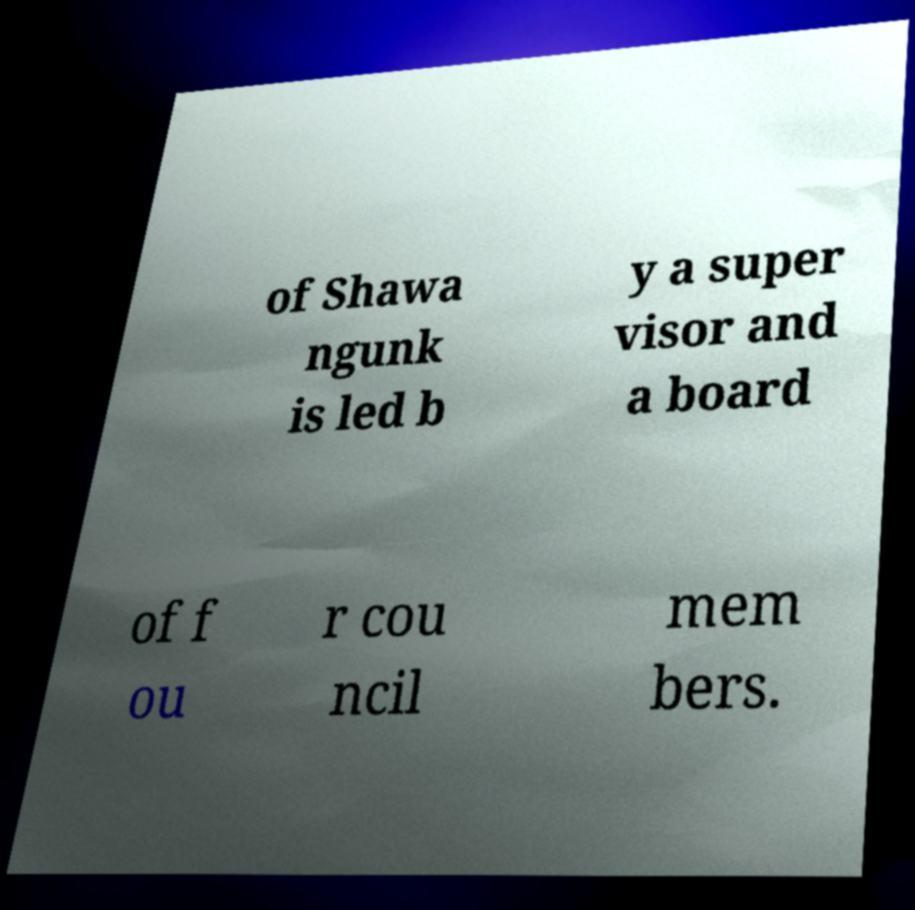For documentation purposes, I need the text within this image transcribed. Could you provide that? of Shawa ngunk is led b y a super visor and a board of f ou r cou ncil mem bers. 